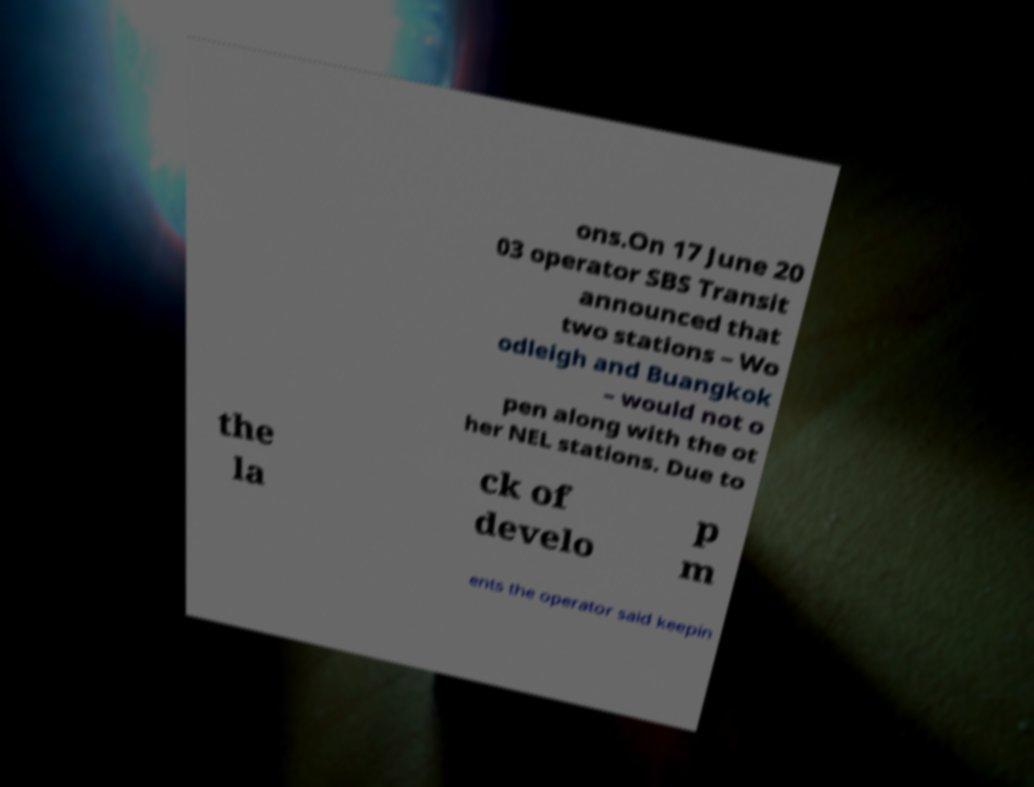Could you assist in decoding the text presented in this image and type it out clearly? ons.On 17 June 20 03 operator SBS Transit announced that two stations – Wo odleigh and Buangkok – would not o pen along with the ot her NEL stations. Due to the la ck of develo p m ents the operator said keepin 